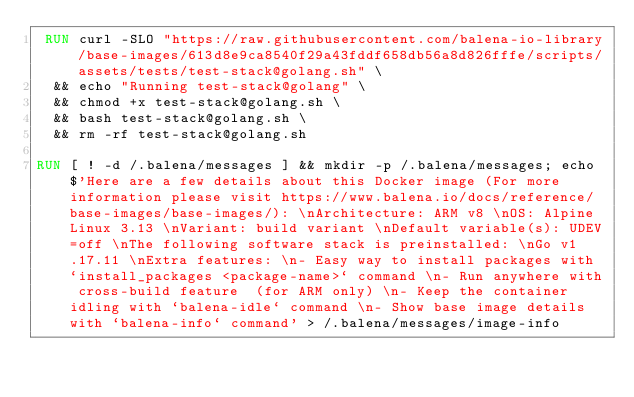Convert code to text. <code><loc_0><loc_0><loc_500><loc_500><_Dockerfile_> RUN curl -SLO "https://raw.githubusercontent.com/balena-io-library/base-images/613d8e9ca8540f29a43fddf658db56a8d826fffe/scripts/assets/tests/test-stack@golang.sh" \
  && echo "Running test-stack@golang" \
  && chmod +x test-stack@golang.sh \
  && bash test-stack@golang.sh \
  && rm -rf test-stack@golang.sh 

RUN [ ! -d /.balena/messages ] && mkdir -p /.balena/messages; echo $'Here are a few details about this Docker image (For more information please visit https://www.balena.io/docs/reference/base-images/base-images/): \nArchitecture: ARM v8 \nOS: Alpine Linux 3.13 \nVariant: build variant \nDefault variable(s): UDEV=off \nThe following software stack is preinstalled: \nGo v1.17.11 \nExtra features: \n- Easy way to install packages with `install_packages <package-name>` command \n- Run anywhere with cross-build feature  (for ARM only) \n- Keep the container idling with `balena-idle` command \n- Show base image details with `balena-info` command' > /.balena/messages/image-info</code> 